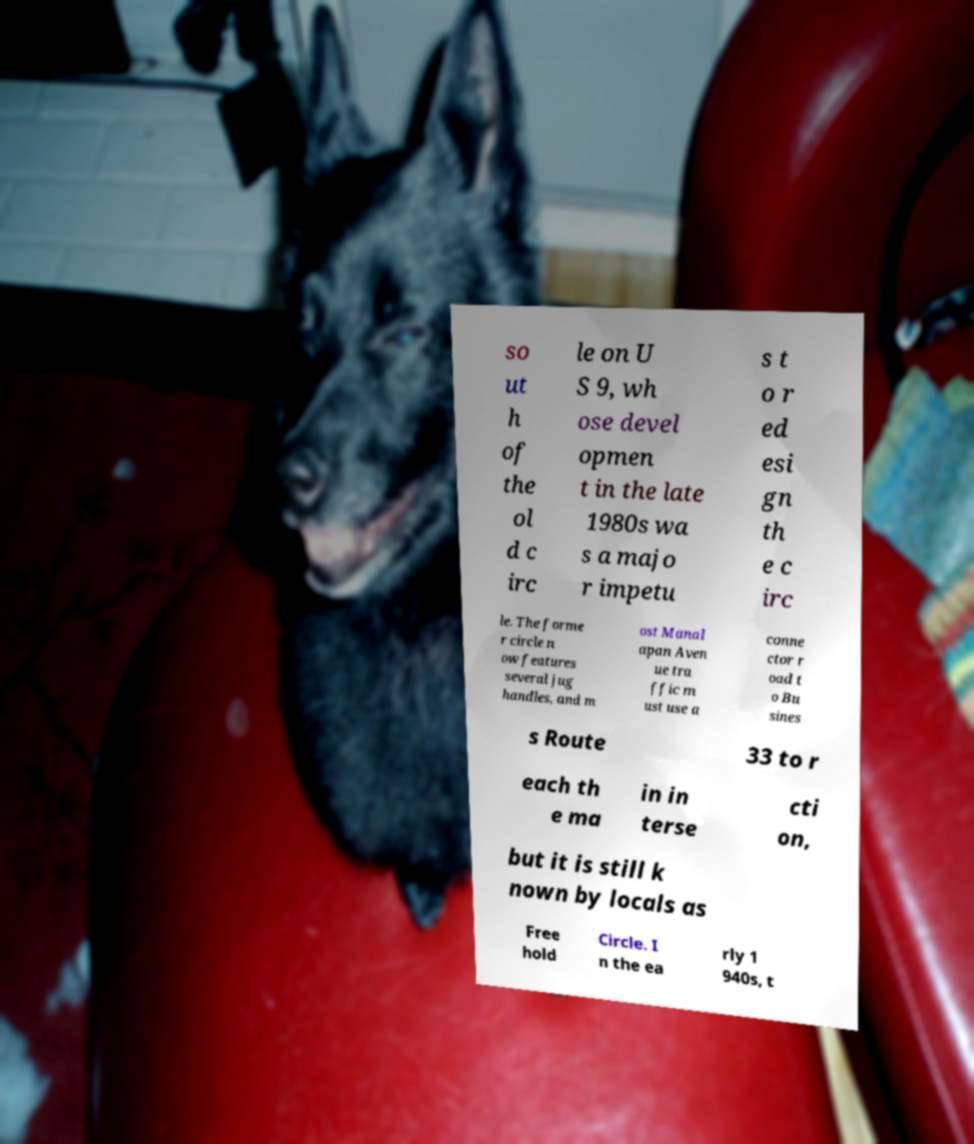I need the written content from this picture converted into text. Can you do that? so ut h of the ol d c irc le on U S 9, wh ose devel opmen t in the late 1980s wa s a majo r impetu s t o r ed esi gn th e c irc le. The forme r circle n ow features several jug handles, and m ost Manal apan Aven ue tra ffic m ust use a conne ctor r oad t o Bu sines s Route 33 to r each th e ma in in terse cti on, but it is still k nown by locals as Free hold Circle. I n the ea rly 1 940s, t 